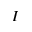<formula> <loc_0><loc_0><loc_500><loc_500>I</formula> 